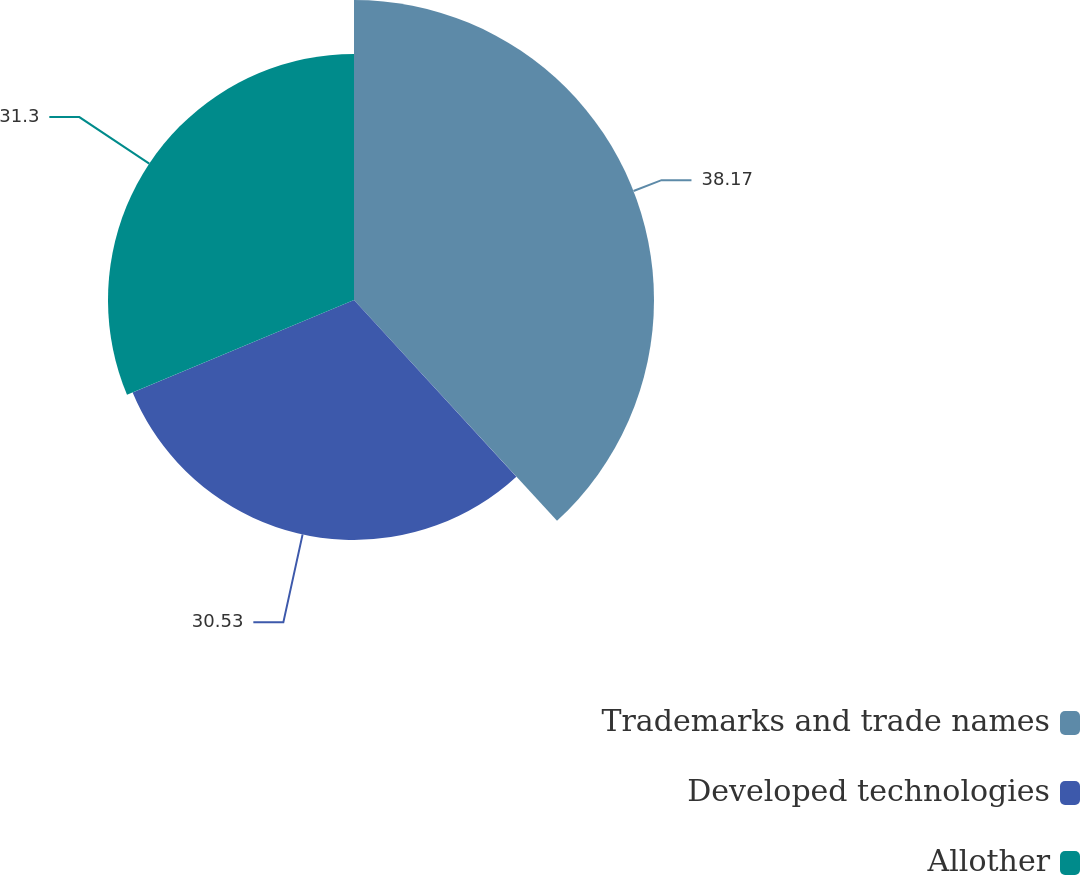Convert chart to OTSL. <chart><loc_0><loc_0><loc_500><loc_500><pie_chart><fcel>Trademarks and trade names<fcel>Developed technologies<fcel>Allother<nl><fcel>38.17%<fcel>30.53%<fcel>31.3%<nl></chart> 